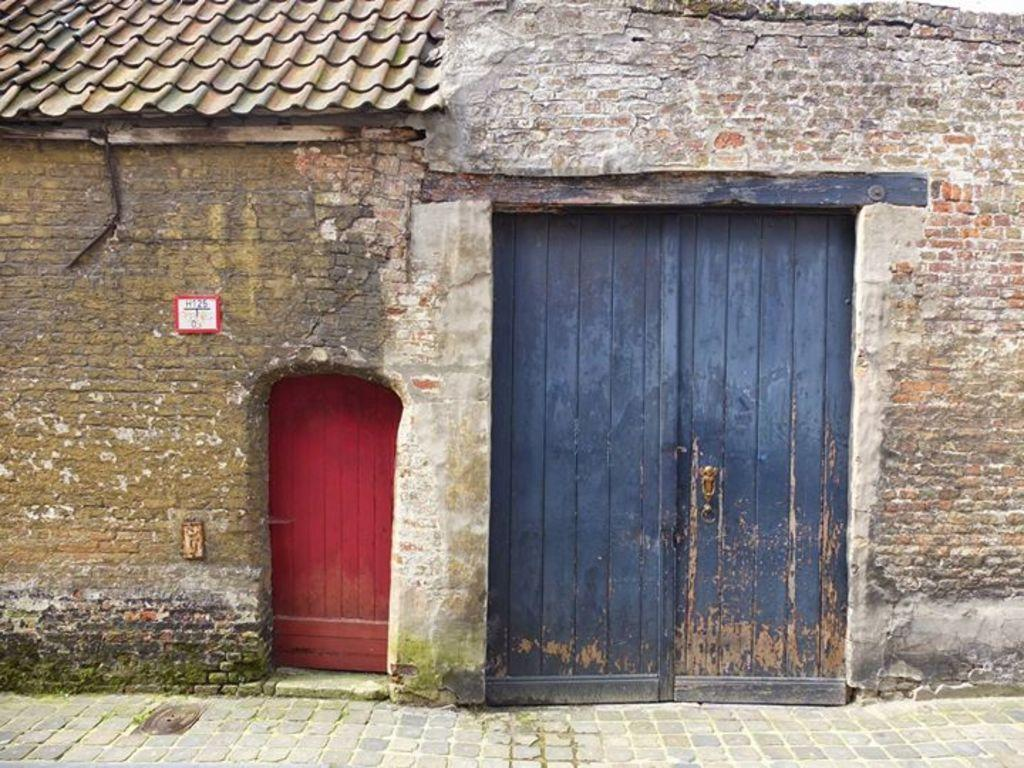What type of structure is present in the image? There is a building in the image. How many doors can be seen on the building? The building has two doors. What is the uppermost part of the building called? The building has a roof. What position does the beetle hold in the building? There is no beetle present in the image, so it cannot hold any position in the building. 